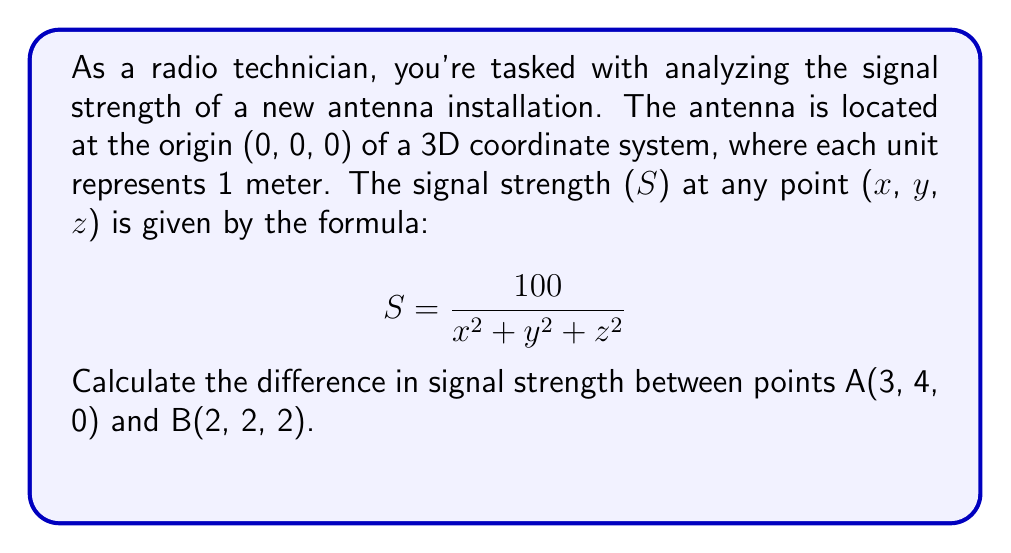Teach me how to tackle this problem. Let's approach this step-by-step:

1) First, we need to calculate the signal strength at point A(3, 4, 0):

   $$ S_A = \frac{100}{3^2 + 4^2 + 0^2} = \frac{100}{9 + 16 + 0} = \frac{100}{25} = 4 $$

2) Now, let's calculate the signal strength at point B(2, 2, 2):

   $$ S_B = \frac{100}{2^2 + 2^2 + 2^2} = \frac{100}{4 + 4 + 4} = \frac{100}{12} = \frac{25}{3} \approx 8.33 $$

3) To find the difference in signal strength, we subtract $S_A$ from $S_B$:

   $$ \text{Difference} = S_B - S_A = \frac{25}{3} - 4 = \frac{25}{3} - \frac{12}{3} = \frac{13}{3} \approx 4.33 $$

Therefore, the difference in signal strength between points A and B is $\frac{13}{3}$ or approximately 4.33 units.
Answer: $\frac{13}{3}$ 